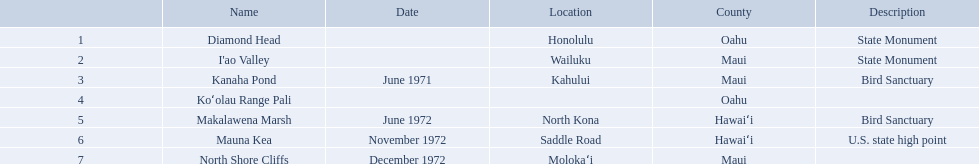Which national natural landmarks in hawaii are in oahu county? Diamond Head, Koʻolau Range Pali. Of these landmarks, which one is listed without a location? Koʻolau Range Pali. What are all of the national natural landmarks in hawaii? Diamond Head, I'ao Valley, Kanaha Pond, Koʻolau Range Pali, Makalawena Marsh, Mauna Kea, North Shore Cliffs. Which ones of those national natural landmarks in hawaii are in the county of hawai'i? Makalawena Marsh, Mauna Kea. Which is the only national natural landmark in hawaii that is also a u.s. state high point? Mauna Kea. What are all of the landmark names in hawaii? Diamond Head, I'ao Valley, Kanaha Pond, Koʻolau Range Pali, Makalawena Marsh, Mauna Kea, North Shore Cliffs. What are their descriptions? State Monument, State Monument, Bird Sanctuary, , Bird Sanctuary, U.S. state high point, . And which is described as a u.s. state high point? Mauna Kea. What are every national natural landmarks present in hawaii? Diamond Head, I'ao Valley, Kanaha Pond, Koʻolau Range Pali, Makalawena Marsh, Mauna Kea, North Shore Cliffs. Which of those national natural landmarks in hawaii can be found in the county of hawai'i? Makalawena Marsh, Mauna Kea. Which is the unique national natural landmark in hawaii that is also a u.s. state high point? Mauna Kea. What are the names of all prominent landmarks in hawaii? Diamond Head, I'ao Valley, Kanaha Pond, Koʻolau Range Pali, Makalawena Marsh, Mauna Kea, North Shore Cliffs. What are their attributes? State Monument, State Monument, Bird Sanctuary, , Bird Sanctuary, U.S. state high point, . And which one is recognized as a u.s. state high point? Mauna Kea. What are the natural features in hawaii (national)? Diamond Head, I'ao Valley, Kanaha Pond, Koʻolau Range Pali, Makalawena Marsh, Mauna Kea, North Shore Cliffs. Of these, which is considered as a u.s. state high point? Mauna Kea. What are the names of all the significant landmarks in hawaii? Diamond Head, I'ao Valley, Kanaha Pond, Koʻolau Range Pali, Makalawena Marsh, Mauna Kea, North Shore Cliffs. What are their characteristics? State Monument, State Monument, Bird Sanctuary, , Bird Sanctuary, U.S. state high point, . And which one is identified as a u.s. state high point? Mauna Kea. What are the names of all the landmarks? Diamond Head, I'ao Valley, Kanaha Pond, Koʻolau Range Pali, Makalawena Marsh, Mauna Kea, North Shore Cliffs. Where is each situated? Honolulu, Wailuku, Kahului, , North Kona, Saddle Road, Molokaʻi. And which landmark doesn't have a location mentioned? Koʻolau Range Pali. Which national natural landmarks in hawaii are situated in oahu county? Diamond Head, Koʻolau Range Pali. Among these landmarks, which one is mentioned without a location? Koʻolau Range Pali. What are the national natural monuments in hawaii? Diamond Head, I'ao Valley, Kanaha Pond, Koʻolau Range Pali, Makalawena Marsh, Mauna Kea, North Shore Cliffs. Which of these are in hawai'i county? Makalawena Marsh, Mauna Kea. Among these, which one has a bird reserve? Makalawena Marsh. What are the national natural wonders in hawaii? Diamond Head, I'ao Valley, Kanaha Pond, Koʻolau Range Pali, Makalawena Marsh, Mauna Kea, North Shore Cliffs. Which of these are in hawai'i county? Makalawena Marsh, Mauna Kea. Of these, which one features a bird refuge? Makalawena Marsh. What are the distinct names for landmarks? Diamond Head, I'ao Valley, Kanaha Pond, Koʻolau Range Pali, Makalawena Marsh, Mauna Kea, North Shore Cliffs. Which one can be found in the county of hawai'i? Makalawena Marsh, Mauna Kea. Which one isn't mauna kea? Makalawena Marsh. 